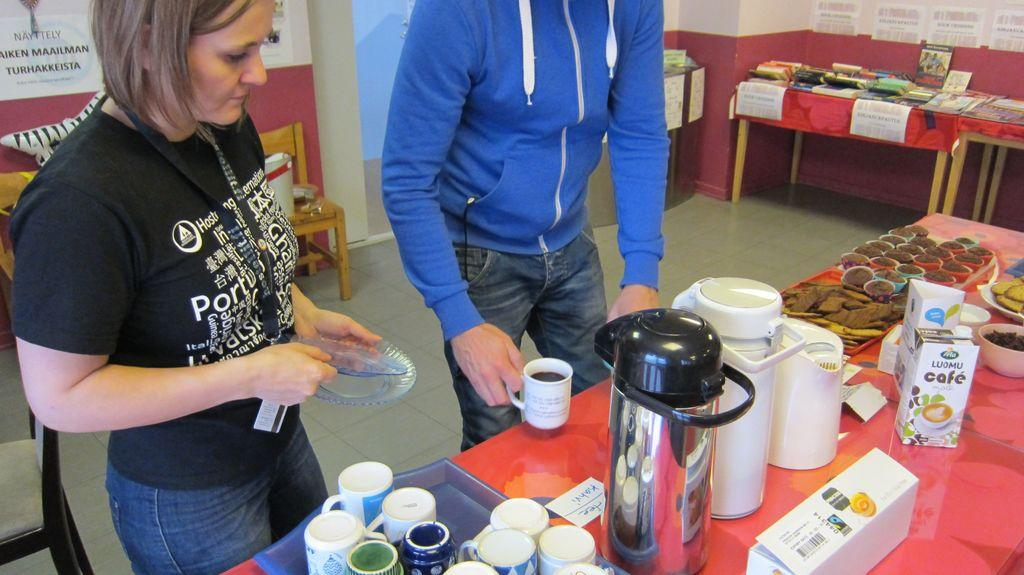<image>
Summarize the visual content of the image. A man in a blue hoodie serves up a beverage in front of a bottle of Luomu Café creamer. 